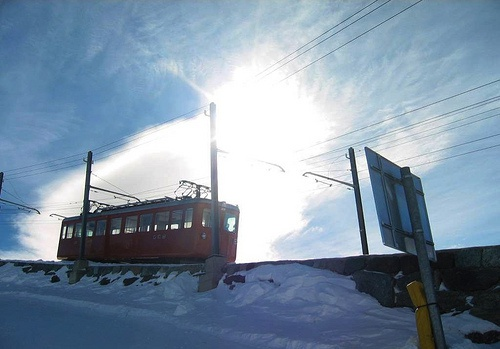Describe the objects in this image and their specific colors. I can see train in blue, black, gray, and white tones and bus in blue, black, gray, and darkblue tones in this image. 